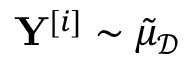Convert formula to latex. <formula><loc_0><loc_0><loc_500><loc_500>Y ^ { [ i ] } \sim \tilde { \mu } _ { \mathcal { D } }</formula> 